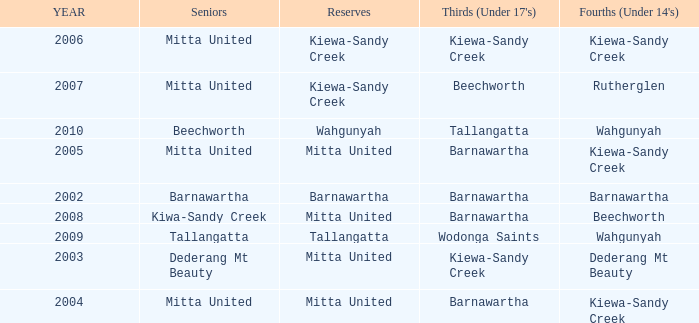Help me parse the entirety of this table. {'header': ['YEAR', 'Seniors', 'Reserves', "Thirds (Under 17's)", "Fourths (Under 14's)"], 'rows': [['2006', 'Mitta United', 'Kiewa-Sandy Creek', 'Kiewa-Sandy Creek', 'Kiewa-Sandy Creek'], ['2007', 'Mitta United', 'Kiewa-Sandy Creek', 'Beechworth', 'Rutherglen'], ['2010', 'Beechworth', 'Wahgunyah', 'Tallangatta', 'Wahgunyah'], ['2005', 'Mitta United', 'Mitta United', 'Barnawartha', 'Kiewa-Sandy Creek'], ['2002', 'Barnawartha', 'Barnawartha', 'Barnawartha', 'Barnawartha'], ['2008', 'Kiwa-Sandy Creek', 'Mitta United', 'Barnawartha', 'Beechworth'], ['2009', 'Tallangatta', 'Tallangatta', 'Wodonga Saints', 'Wahgunyah'], ['2003', 'Dederang Mt Beauty', 'Mitta United', 'Kiewa-Sandy Creek', 'Dederang Mt Beauty'], ['2004', 'Mitta United', 'Mitta United', 'Barnawartha', 'Kiewa-Sandy Creek']]} Which Thirds (Under 17's) have a Reserve of barnawartha? Barnawartha. 